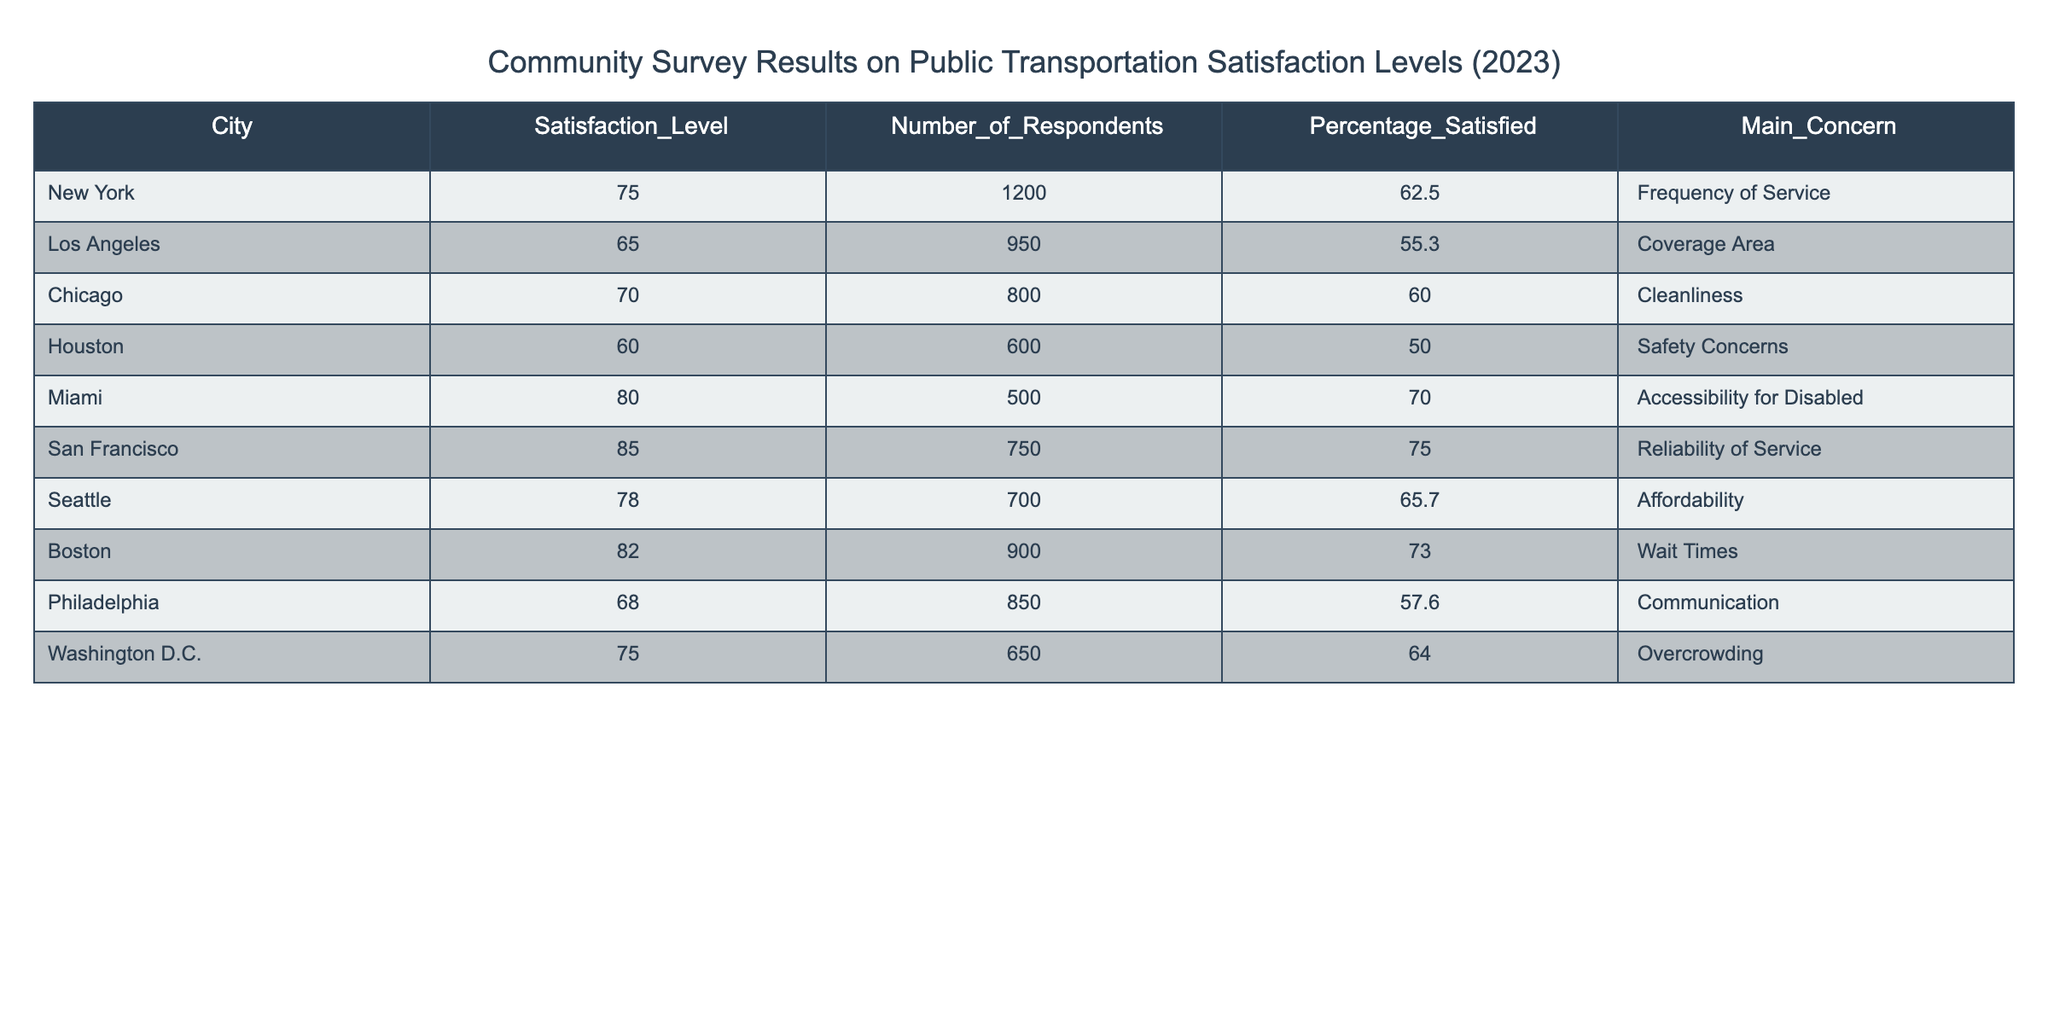What is the percentage of respondents satisfied with public transportation in New York? According to the table, the percentage satisfied in New York is explicitly listed as 62.5.
Answer: 62.5 Which city has the highest satisfaction level, and what is that level? The table shows that San Francisco has the highest satisfaction level at 85.
Answer: San Francisco, 85 What is the average satisfaction level across all cities listed in the survey? To find the average satisfaction level, we sum the satisfaction levels (75 + 65 + 70 + 60 + 80 + 85 + 78 + 82 + 68 + 75 =  785) and divide by the number of cities (10). The average is 785 / 10 = 78.5.
Answer: 78.5 Is the percentage of satisfied respondents in Chicago greater than 60%? According to the table, the percentage satisfied in Chicago is 60.0, which is not greater than 60%.
Answer: No Which city reported the main concern regarding "Frequency of Service," and what is its satisfaction level? Based on the table, New York reported the main concern of "Frequency of Service," with a satisfaction level of 75.
Answer: New York, 75 What is the difference in the number of respondents between San Francisco and Miami? The number of respondents in San Francisco is 750 and in Miami is 500. The difference is 750 - 500 = 250.
Answer: 250 Does Washington D.C. have a higher percentage of satisfied respondents than Los Angeles? The percentage satisfied in Washington D.C. is 64.0, while in Los Angeles it is 55.3. Since 64.0 is greater than 55.3, the answer is yes.
Answer: Yes What are the main concerns listed for the cities with satisfaction levels above 70? The cities with satisfaction levels above 70 are Miami (Accessibility for Disabled), San Francisco (Reliability of Service), Boston (Wait Times), and New York (Frequency of Service).
Answer: Miami, San Francisco, Boston, New York What is the total number of respondents from all cities in the table, and what does that indicate about the survey's comprehensiveness? By adding the number of respondents (1200 + 950 + 800 + 600 + 500 + 750 + 700 + 900 + 850 + 650 = 6300), the total is 6300. This indicates a broad sample size for the survey, which can provide a reliable representation of public transportation satisfaction.
Answer: 6300 